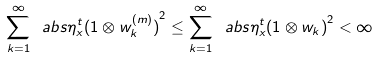Convert formula to latex. <formula><loc_0><loc_0><loc_500><loc_500>\sum _ { k = 1 } ^ { \infty } \ a b s { { \eta ^ { t } _ { x } } ( 1 \otimes w ^ { ( m ) } _ { k } ) } ^ { 2 } \leq \sum _ { k = 1 } ^ { \infty } \ a b s { \eta _ { x } ^ { t } ( 1 \otimes w _ { k } ) } ^ { 2 } < \infty</formula> 